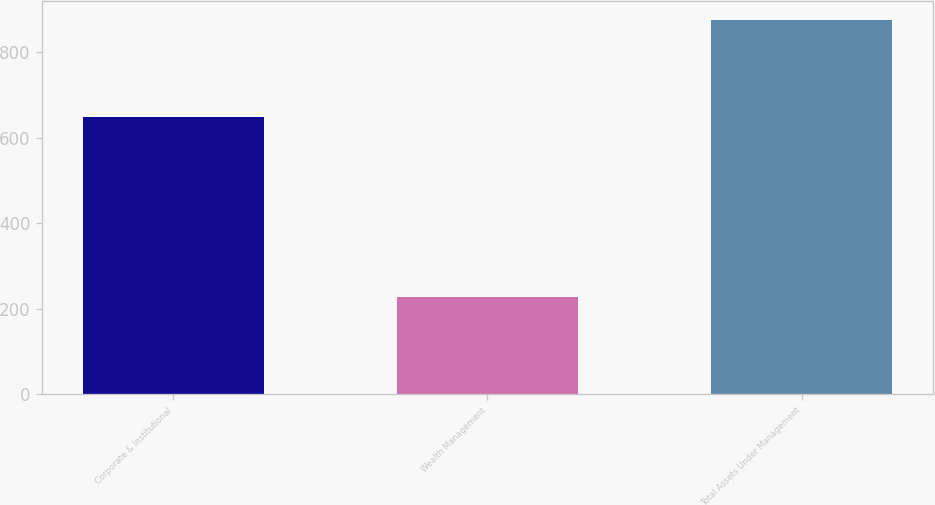Convert chart. <chart><loc_0><loc_0><loc_500><loc_500><bar_chart><fcel>Corporate & Institutional<fcel>Wealth Management<fcel>Total Assets Under Management<nl><fcel>648<fcel>227.3<fcel>875.3<nl></chart> 